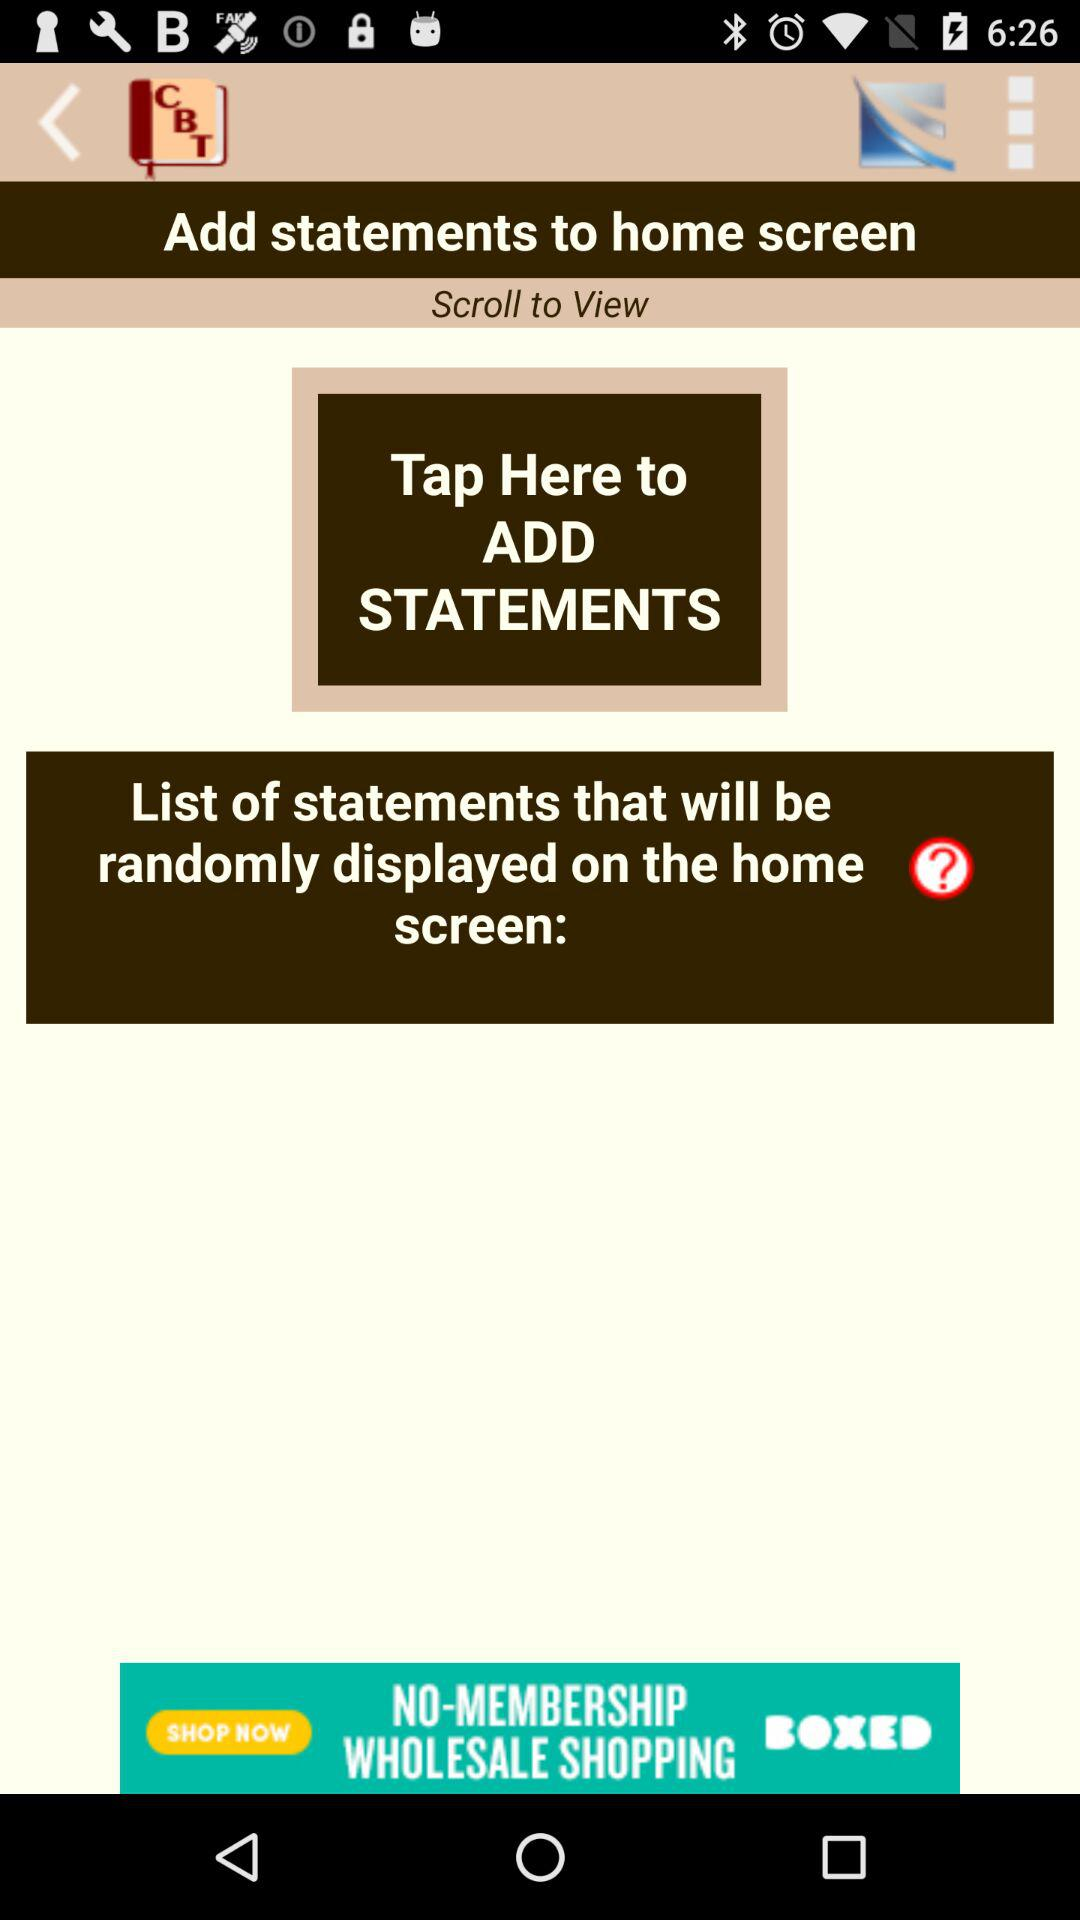How many statements have been added?
When the provided information is insufficient, respond with <no answer>. <no answer> 